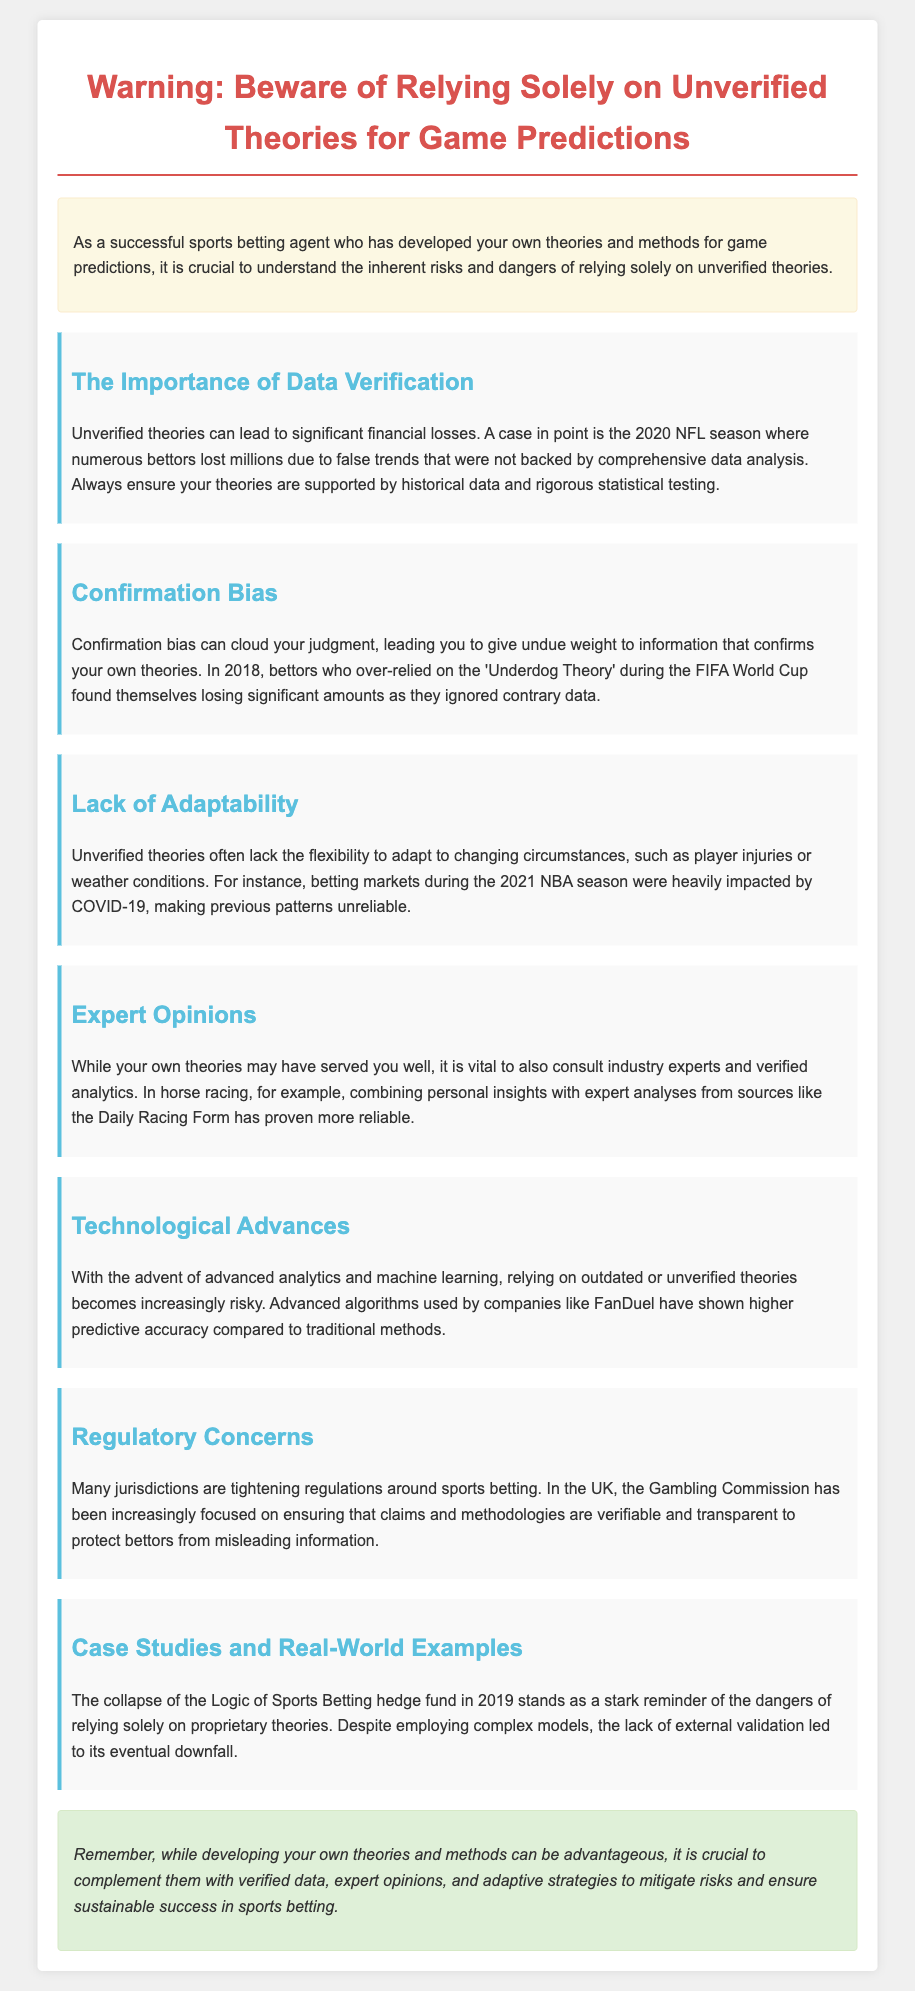What is a major risk of relying on unverified theories? The document states that unverified theories can lead to significant financial losses.
Answer: Financial losses What year did bettors lose millions due to false trends? The document mentions the 2020 NFL season as a specific instance of bettors losing money.
Answer: 2020 What psychological bias can affect judgment in betting? The document highlights confirmation bias as a specific issue that can cloud judgment.
Answer: Confirmation bias Which season had betting markets impacted by COVID-19? The document refers to the 2021 NBA season as being heavily impacted by COVID-19.
Answer: 2021 What is advised to combine with personal insights in horse racing? The text recommends consulting expert analyses from sources like the Daily Racing Form.
Answer: Expert analyses What advanced tools are mentioned as alternatives to unverified theories? The document refers to advanced analytics and machine learning as more reliable methods.
Answer: Advanced analytics and machine learning What regulatory body is mentioned concerning sports betting in the UK? The document mentions the Gambling Commission as focusing on verifiable claims and methodologies.
Answer: Gambling Commission What year did the Logic of Sports Betting hedge fund collapse? The document notes the collapse occurred in 2019.
Answer: 2019 What is emphasized as necessary to ensure sustainable success in sports betting? The document stresses the importance of verifying data, expert opinions, and adaptive strategies.
Answer: Verifying data, expert opinions, and adaptive strategies 